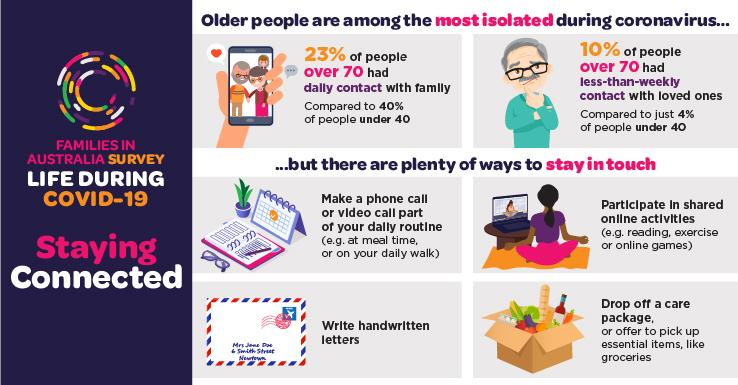Specify some key components in this picture. During the COVID-19 pandemic, a significant proportion of Australians aged 70 or older reported not having daily contact with their families. In fact, 77% of this age group reported not having daily contact with their families during the pandemic. During the COVID-19 pandemic, a significant percentage of Australians aged under 40 reported having daily contact with their families. In particular, approximately 40% of this age group reported maintaining regular daily contact with their families while the pandemic was ongoing. During the COVID-19 pandemic, a small percentage of Australians aged under 40 reported having less than weekly contact with their families, with 4% stating this was the case. 